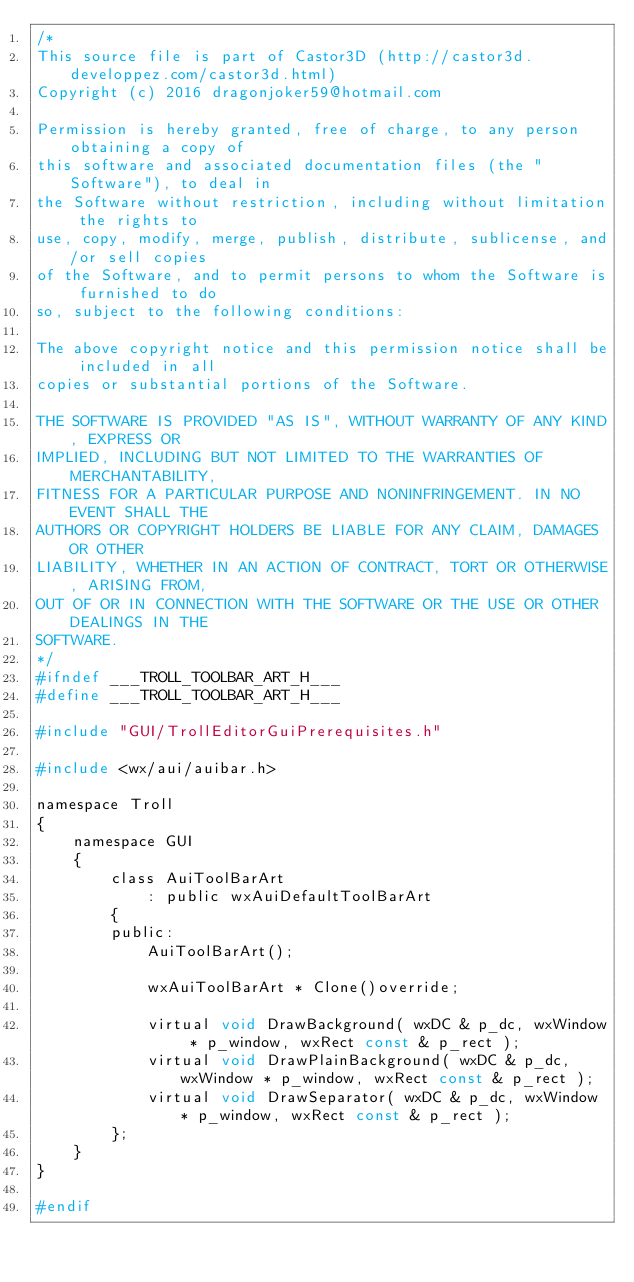Convert code to text. <code><loc_0><loc_0><loc_500><loc_500><_C_>/*
This source file is part of Castor3D (http://castor3d.developpez.com/castor3d.html)
Copyright (c) 2016 dragonjoker59@hotmail.com

Permission is hereby granted, free of charge, to any person obtaining a copy of
this software and associated documentation files (the "Software"), to deal in
the Software without restriction, including without limitation the rights to
use, copy, modify, merge, publish, distribute, sublicense, and/or sell copies
of the Software, and to permit persons to whom the Software is furnished to do
so, subject to the following conditions:

The above copyright notice and this permission notice shall be included in all
copies or substantial portions of the Software.

THE SOFTWARE IS PROVIDED "AS IS", WITHOUT WARRANTY OF ANY KIND, EXPRESS OR
IMPLIED, INCLUDING BUT NOT LIMITED TO THE WARRANTIES OF MERCHANTABILITY,
FITNESS FOR A PARTICULAR PURPOSE AND NONINFRINGEMENT. IN NO EVENT SHALL THE
AUTHORS OR COPYRIGHT HOLDERS BE LIABLE FOR ANY CLAIM, DAMAGES OR OTHER
LIABILITY, WHETHER IN AN ACTION OF CONTRACT, TORT OR OTHERWISE, ARISING FROM,
OUT OF OR IN CONNECTION WITH THE SOFTWARE OR THE USE OR OTHER DEALINGS IN THE
SOFTWARE.
*/
#ifndef ___TROLL_TOOLBAR_ART_H___
#define ___TROLL_TOOLBAR_ART_H___

#include "GUI/TrollEditorGuiPrerequisites.h"

#include <wx/aui/auibar.h>

namespace Troll
{
	namespace GUI
	{
		class AuiToolBarArt
			: public wxAuiDefaultToolBarArt
		{
		public:
			AuiToolBarArt();

			wxAuiToolBarArt * Clone()override;

			virtual void DrawBackground( wxDC & p_dc, wxWindow * p_window, wxRect const & p_rect );
			virtual void DrawPlainBackground( wxDC & p_dc, wxWindow * p_window, wxRect const & p_rect );
			virtual void DrawSeparator( wxDC & p_dc, wxWindow * p_window, wxRect const & p_rect );
		};
	}
}

#endif
</code> 